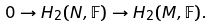Convert formula to latex. <formula><loc_0><loc_0><loc_500><loc_500>0 \rightarrow H _ { 2 } ( N , { \mathbb { F } } ) \rightarrow H _ { 2 } ( M , { \mathbb { F } } ) .</formula> 